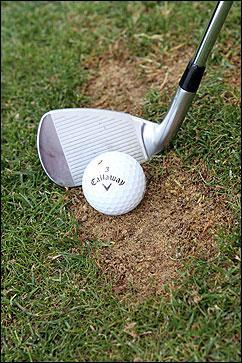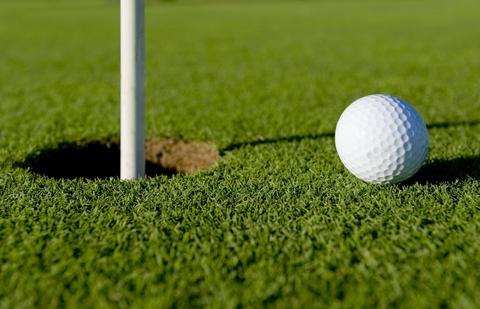The first image is the image on the left, the second image is the image on the right. Given the left and right images, does the statement "An image shows a golf club behind a ball that is not on a tee." hold true? Answer yes or no. Yes. 